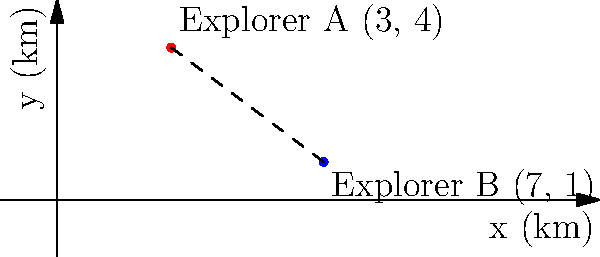In a dense forest, two explorers are trying to rendezvous. Explorer A is at coordinates (3, 4) and Explorer B is at coordinates (7, 1), where the units are in kilometers. Using the distance formula, calculate the straight-line distance between the two explorers. Round your answer to the nearest tenth of a kilometer. To solve this problem, we'll use the distance formula derived from the Pythagorean theorem:

$$d = \sqrt{(x_2 - x_1)^2 + (y_2 - y_1)^2}$$

Where:
$(x_1, y_1)$ is the position of Explorer A (3, 4)
$(x_2, y_2)$ is the position of Explorer B (7, 1)

Let's plug these values into the formula:

$$d = \sqrt{(7 - 3)^2 + (1 - 4)^2}$$

Simplify inside the parentheses:
$$d = \sqrt{4^2 + (-3)^2}$$

Calculate the squares:
$$d = \sqrt{16 + 9}$$

Add inside the square root:
$$d = \sqrt{25}$$

Calculate the square root:
$$d = 5$$

The exact distance is 5 kilometers. Since the question asks for the answer rounded to the nearest tenth, our final answer remains 5.0 km.
Answer: 5.0 km 